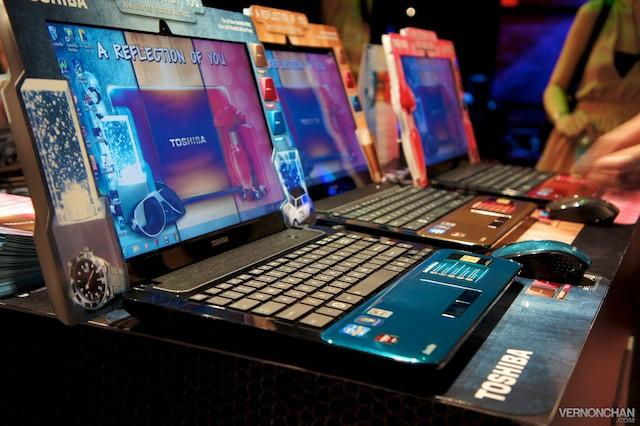What kind of label is on the desk? toshiba 